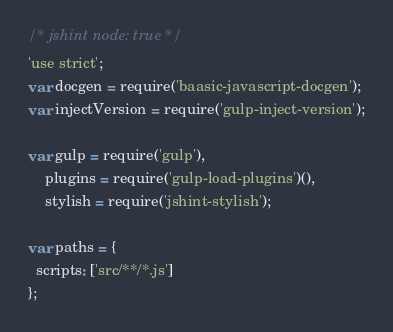Convert code to text. <code><loc_0><loc_0><loc_500><loc_500><_JavaScript_>/* jshint node: true */
'use strict';
var docgen = require('baasic-javascript-docgen');
var injectVersion = require('gulp-inject-version');

var gulp = require('gulp'),
	plugins = require('gulp-load-plugins')(),
	stylish = require('jshint-stylish');

var paths = {
  scripts: ['src/**/*.js']
};
</code> 